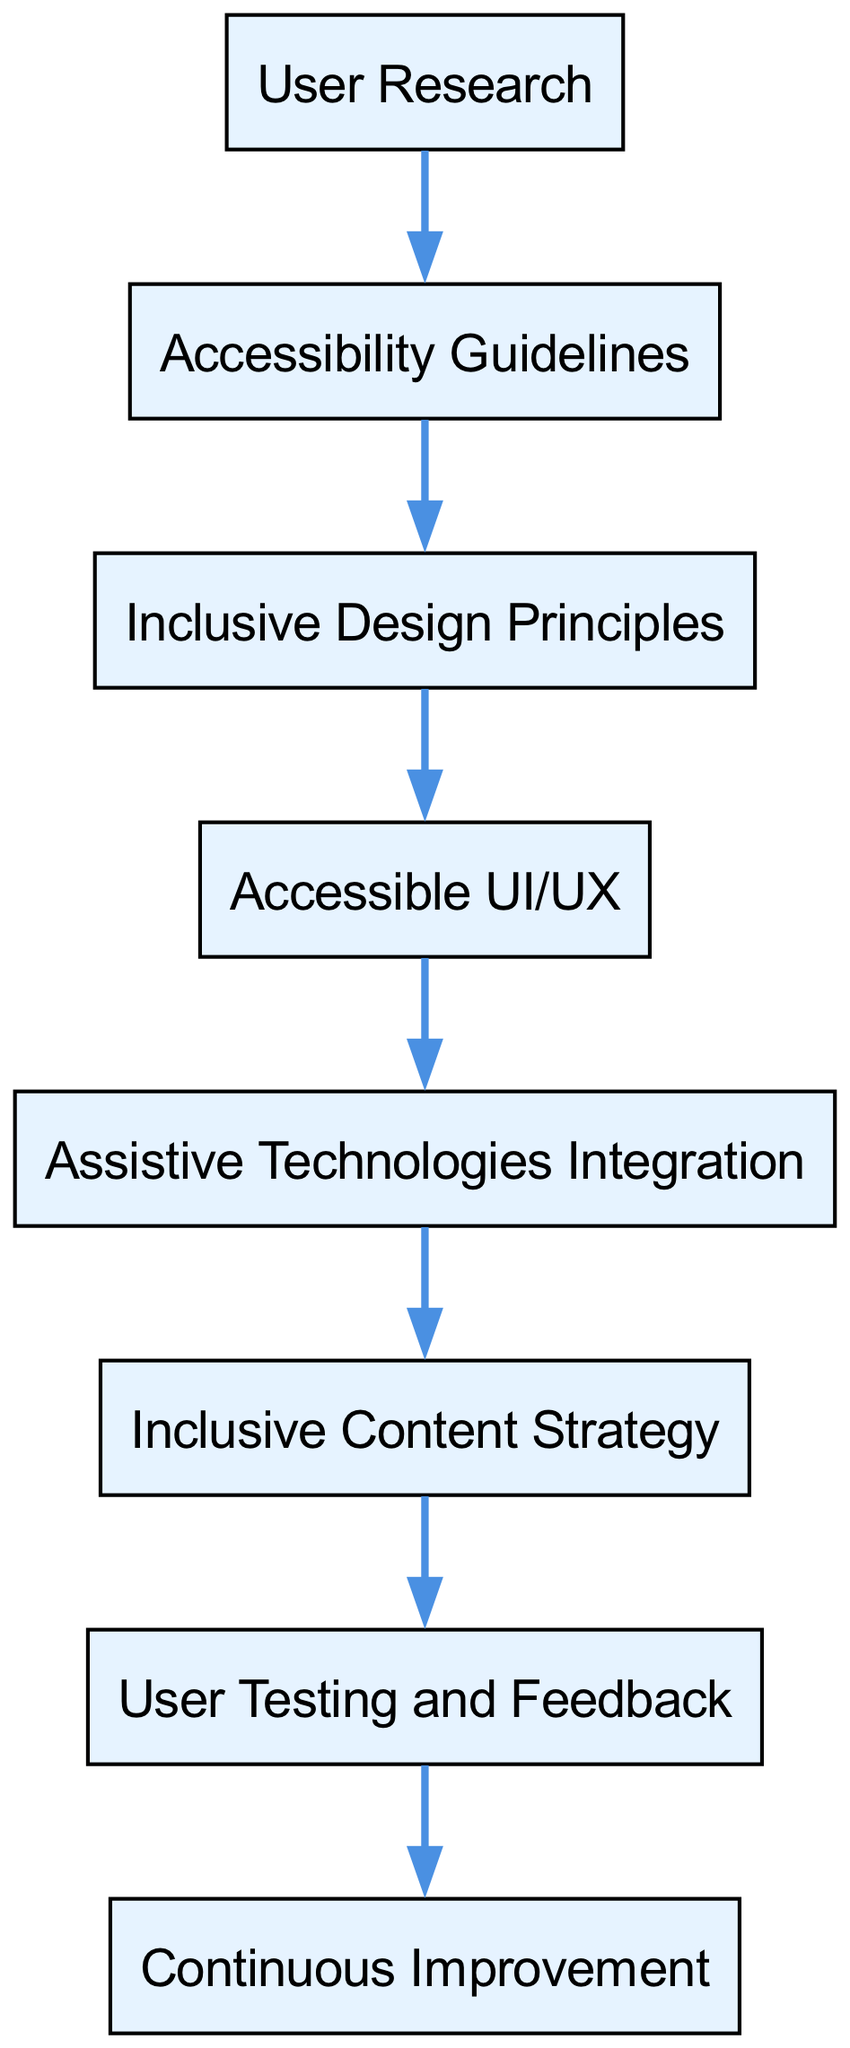What is the starting point of the inclusive technology adoption journey? The diagram shows "User Research" as the only node with no incoming edges, indicating it is the starting point of the journey.
Answer: User Research How many nodes are in the diagram? By counting the different elements (nodes) presented in the diagram, there are a total of eight nodes.
Answer: 8 Which element directly consumes "User Research"? The flow of the diagram indicates that "Accessibility Guidelines" is the only element that consumes "User Research" directly.
Answer: Accessibility Guidelines What is the final step in the inclusive technology adoption journey? The last element in the flow, which indicates the conclusion of the process, is "Continuous Improvement."
Answer: Continuous Improvement Which node is consumed by "Assistive Technologies Integration"? The flow indicates that "Inclusive Content Strategy" is the element that is consumed by "Assistive Technologies Integration."
Answer: Inclusive Content Strategy Which two elements do not directly consume any other nodes? Upon reviewing the diagram, it is clear that "User Research" and "Continuous Improvement" do not have incoming edges and therefore do not consume any other nodes.
Answer: User Research, Continuous Improvement How many edges are in the diagram? After counting the directed connections (edges) between the elements of the diagram, there are a total of seven edges representing the consumption relationships.
Answer: 7 What is the relationship between "Accessible UI/UX" and "Assistive Technologies Integration"? "Accessible UI/UX" is a prerequisite for "Assistive Technologies Integration," indicating that it must be consumed first for integration to occur.
Answer: Accessible UI/UX Which element is a prerequisite for "User Testing and Feedback"? According to the diagram, the prerequisite for "User Testing and Feedback" is "Inclusive Content Strategy," establishing a direct flow to this element.
Answer: Inclusive Content Strategy 